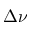Convert formula to latex. <formula><loc_0><loc_0><loc_500><loc_500>\Delta \nu</formula> 